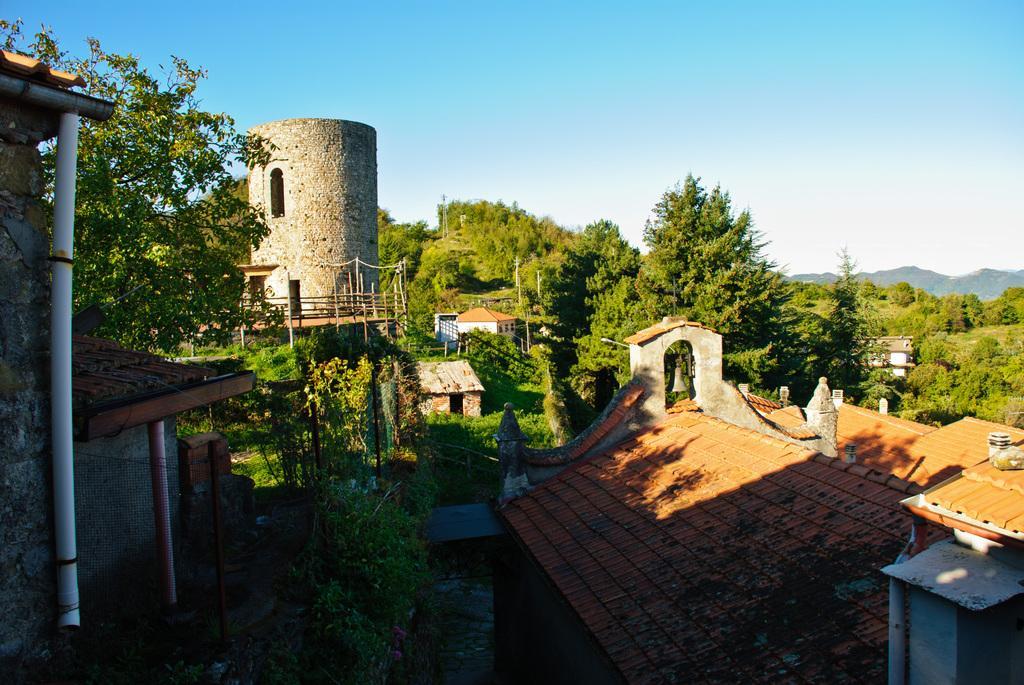How would you summarize this image in a sentence or two? In this image I can see few buildings, windows, net fencing, trees, railing, mountains, bell and the sky. 